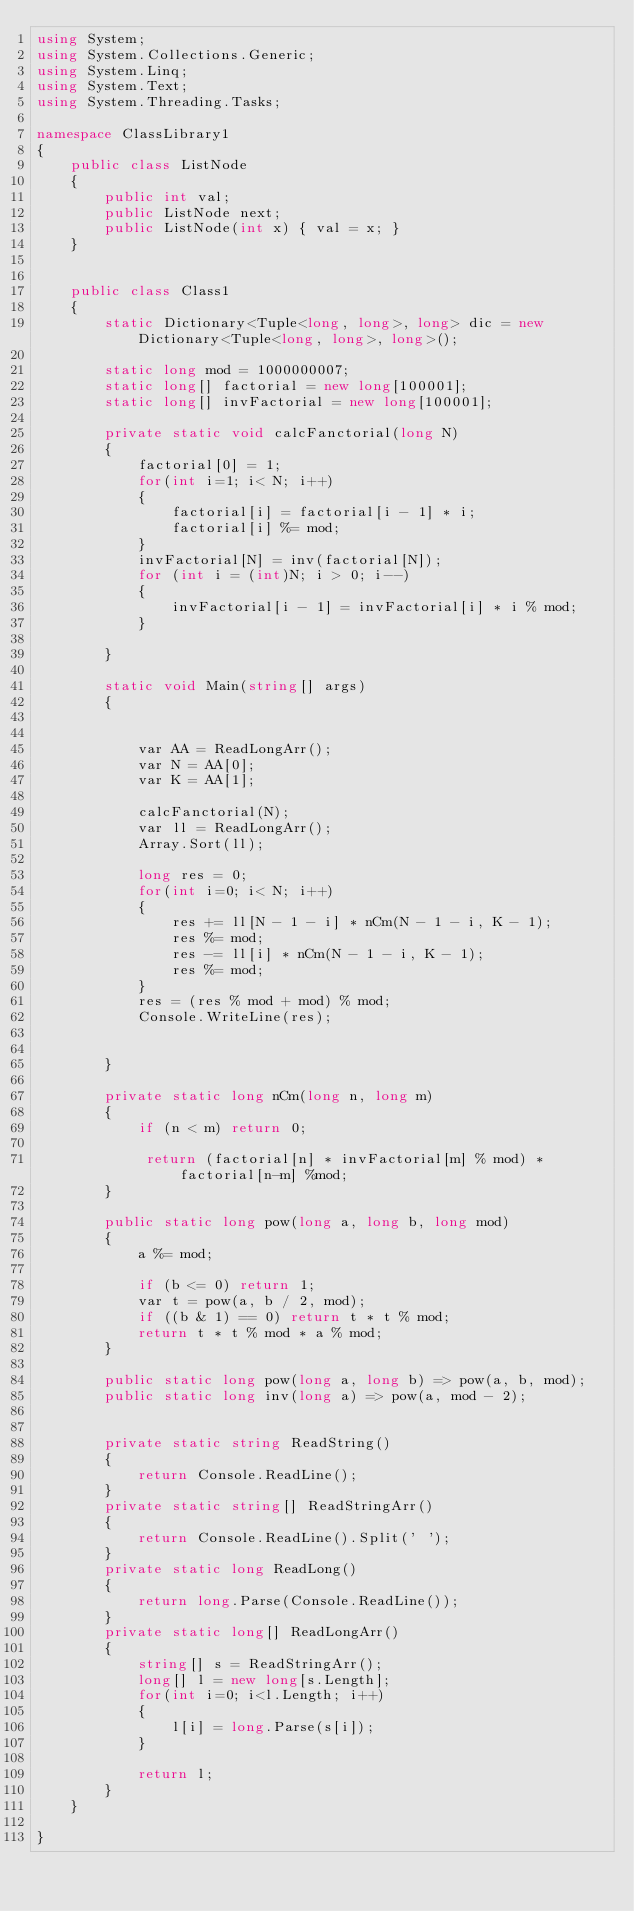Convert code to text. <code><loc_0><loc_0><loc_500><loc_500><_C#_>using System;
using System.Collections.Generic;
using System.Linq;
using System.Text;
using System.Threading.Tasks;

namespace ClassLibrary1
{
    public class ListNode
    {
        public int val;
        public ListNode next;
        public ListNode(int x) { val = x; }
    }


    public class Class1
    {
        static Dictionary<Tuple<long, long>, long> dic = new Dictionary<Tuple<long, long>, long>();

        static long mod = 1000000007;
        static long[] factorial = new long[100001];
        static long[] invFactorial = new long[100001];

        private static void calcFanctorial(long N)
        {
            factorial[0] = 1;
            for(int i=1; i< N; i++)
            {
                factorial[i] = factorial[i - 1] * i;
                factorial[i] %= mod;
            }
            invFactorial[N] = inv(factorial[N]);
            for (int i = (int)N; i > 0; i--)
            {
                invFactorial[i - 1] = invFactorial[i] * i % mod;
            }

        }

        static void Main(string[] args)
        {


            var AA = ReadLongArr();
            var N = AA[0];
            var K = AA[1];

            calcFanctorial(N);
            var ll = ReadLongArr();
            Array.Sort(ll);

            long res = 0;
            for(int i=0; i< N; i++)
            {
                res += ll[N - 1 - i] * nCm(N - 1 - i, K - 1);
                res %= mod;
                res -= ll[i] * nCm(N - 1 - i, K - 1);
                res %= mod;
            }
            res = (res % mod + mod) % mod;
            Console.WriteLine(res);


        }

        private static long nCm(long n, long m)
        {
            if (n < m) return 0;

             return (factorial[n] * invFactorial[m] % mod) * factorial[n-m] %mod;
        }

        public static long pow(long a, long b, long mod)
        {
            a %= mod;

            if (b <= 0) return 1;
            var t = pow(a, b / 2, mod);
            if ((b & 1) == 0) return t * t % mod;
            return t * t % mod * a % mod;
        }

        public static long pow(long a, long b) => pow(a, b, mod);
        public static long inv(long a) => pow(a, mod - 2);


        private static string ReadString()
        {
            return Console.ReadLine();
        }
        private static string[] ReadStringArr()
        {
            return Console.ReadLine().Split(' ');
        }
        private static long ReadLong()
        {
            return long.Parse(Console.ReadLine());
        }
        private static long[] ReadLongArr()
        {
            string[] s = ReadStringArr();
            long[] l = new long[s.Length];
            for(int i=0; i<l.Length; i++)
            {
                l[i] = long.Parse(s[i]);
            }

            return l;
        }
    }

}
</code> 